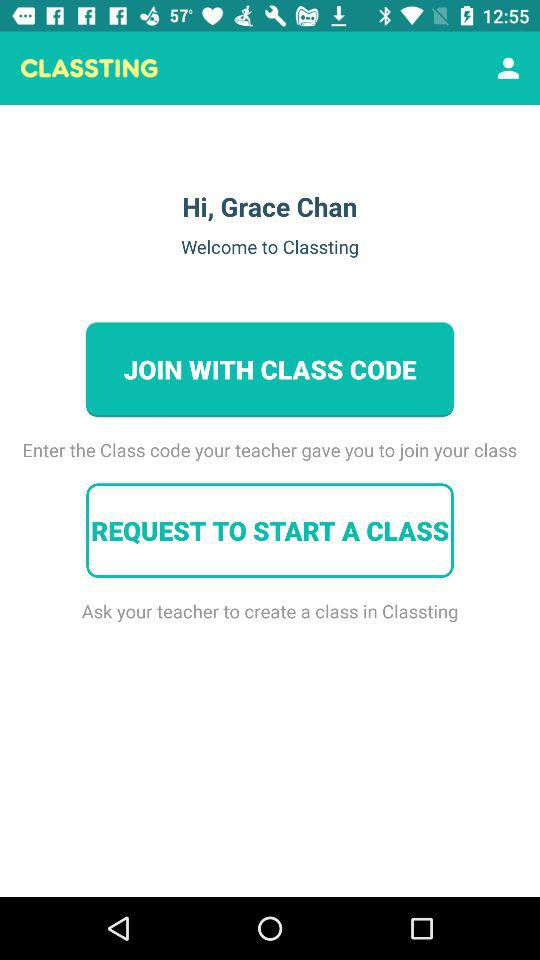What is the class code?
When the provided information is insufficient, respond with <no answer>. <no answer> 